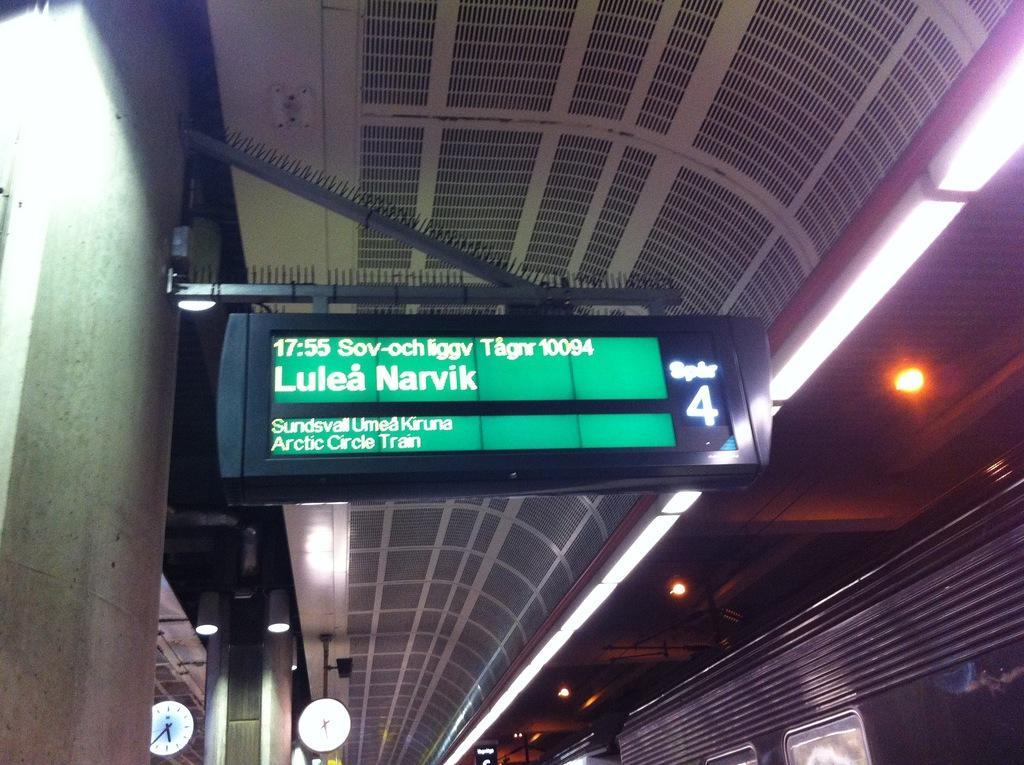Could you give a brief overview of what you see in this image? In this image we can see a signboard with some text on it which is attached to a wall. We can also see some ceiling lights to a roof. On the bottom of the image we can see some lights, clocks and a wagon. 